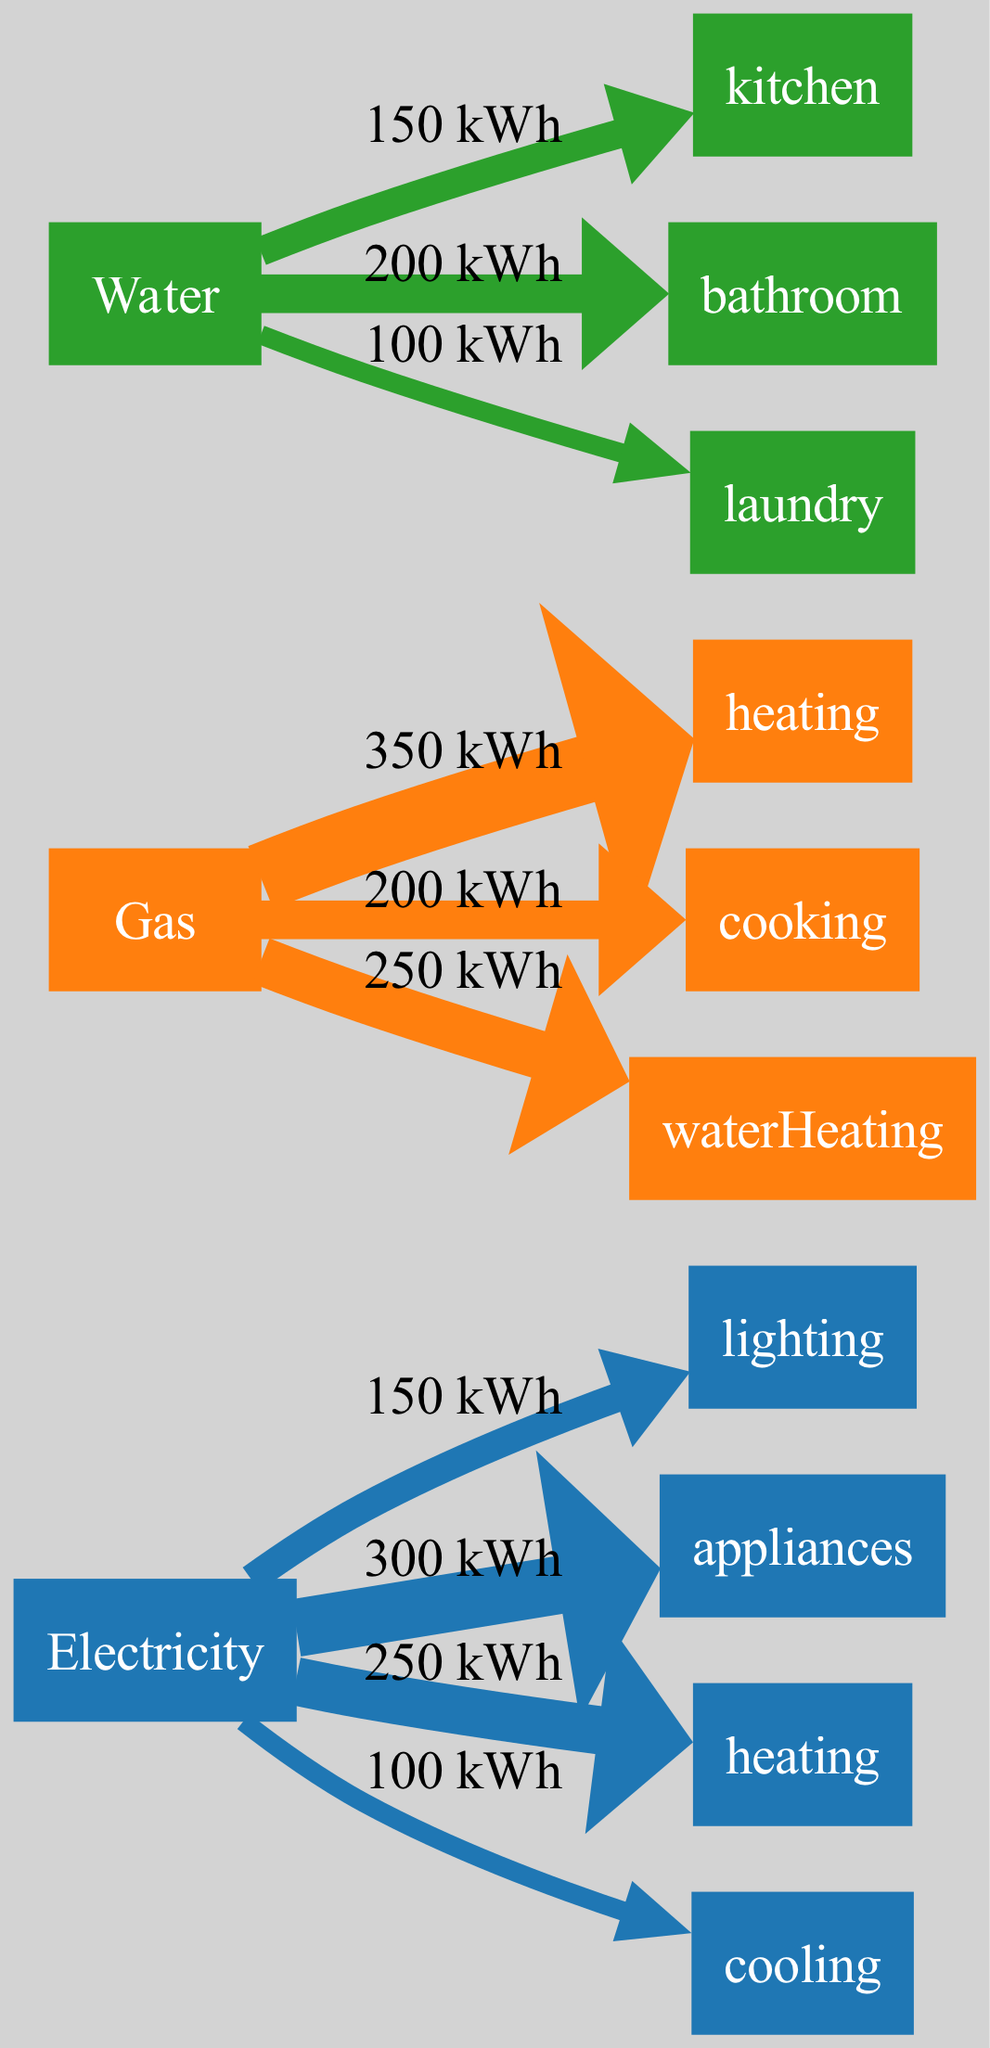What is the total electricity usage? To find the total electricity usage, we add the individual usage values for lighting, appliances, heating, and cooling: 150 + 300 + 250 + 100 = 800 kWh.
Answer: 800 kWh Which energy source has the highest usage for heating? Observing the diagram, gas has a heating usage of 350 kWh, while electricity has heating usage of 250 kWh. Thus, gas has the highest usage for heating.
Answer: Gas How much energy is used for cooking? Looking at the gas usage section of the diagram, cooking has a usage value of 200 kWh.
Answer: 200 kWh What is the total usage for water in the laundry? Within the water usage section, the laundry is noted to have an individual usage of 100 kWh.
Answer: 100 kWh Which category contributes the least to electricity usage? Analyzing the individual electricity usage values, cooling is the lowest at 100 kWh when compared to lighting, appliances, and heating.
Answer: Cooling What is the total gas usage? To determine total gas usage, sum the individual usages for heating, cooking, and water heating: 350 + 200 + 250 = 800 kWh.
Answer: 800 kWh Is the total water usage greater than the total electricity usage? First, we sum the water usage: 150 + 200 + 100 = 450 kWh. Then, we know total electricity usage is 800 kWh. Comparing both, 450 kWh (water) is less than 800 kWh (electricity).
Answer: No Which type of appliance accounts for the least electricity usage? Among the electricity usage types, we compare lighting (150 kWh), appliances (300 kWh), heating (250 kWh), and cooling (100 kWh). Cooling has the least usage at 100 kWh.
Answer: Cooling 